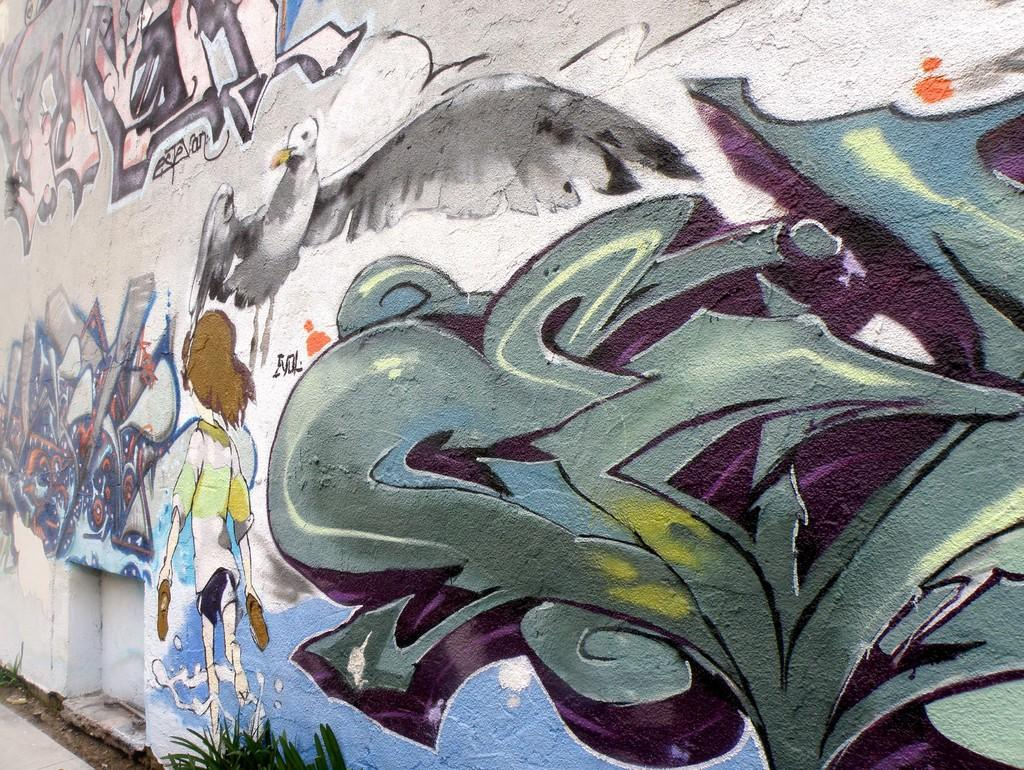What is present on the wall in the image? The wall has paintings on it. Can you describe the style of the paintings? The paintings resemble graffiti. What is located at the bottom of the image? There is a ground at the bottom of the image. What type of vegetation can be seen on the ground? There is a plant on the ground. What type of cable is hanging from the plant in the image? There is no cable present in the image; it features a wall with graffiti-style paintings, a ground, and a plant. What design is visible on the plate in the image? There is no plate present in the image. 